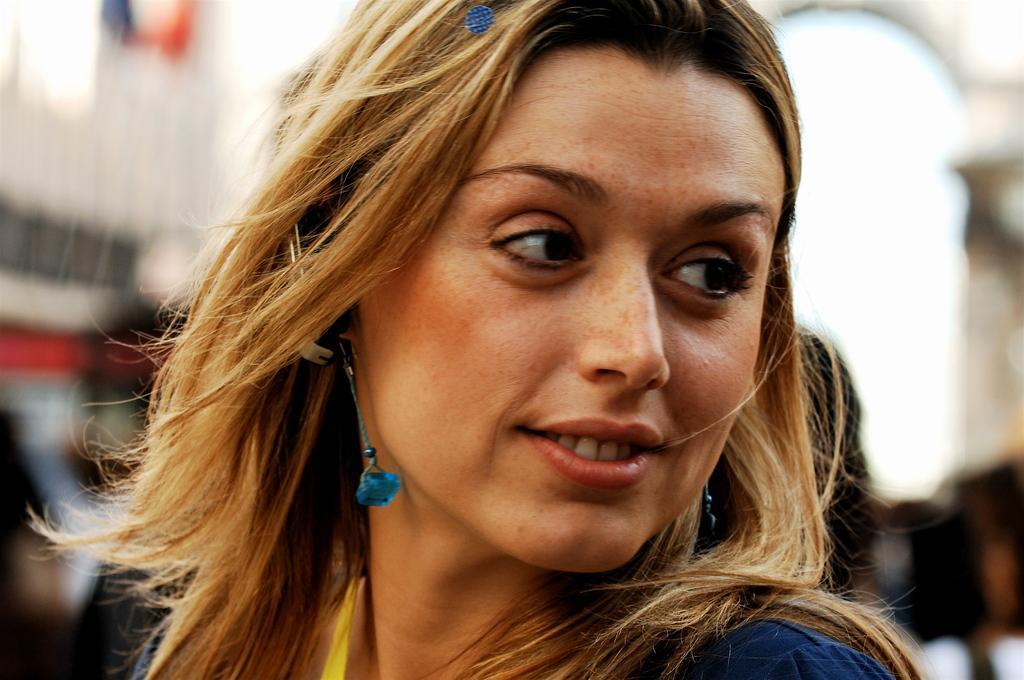In one or two sentences, can you explain what this image depicts? In this image I can see the person and the person is wearing blue color dress and I can see the blurred background. 